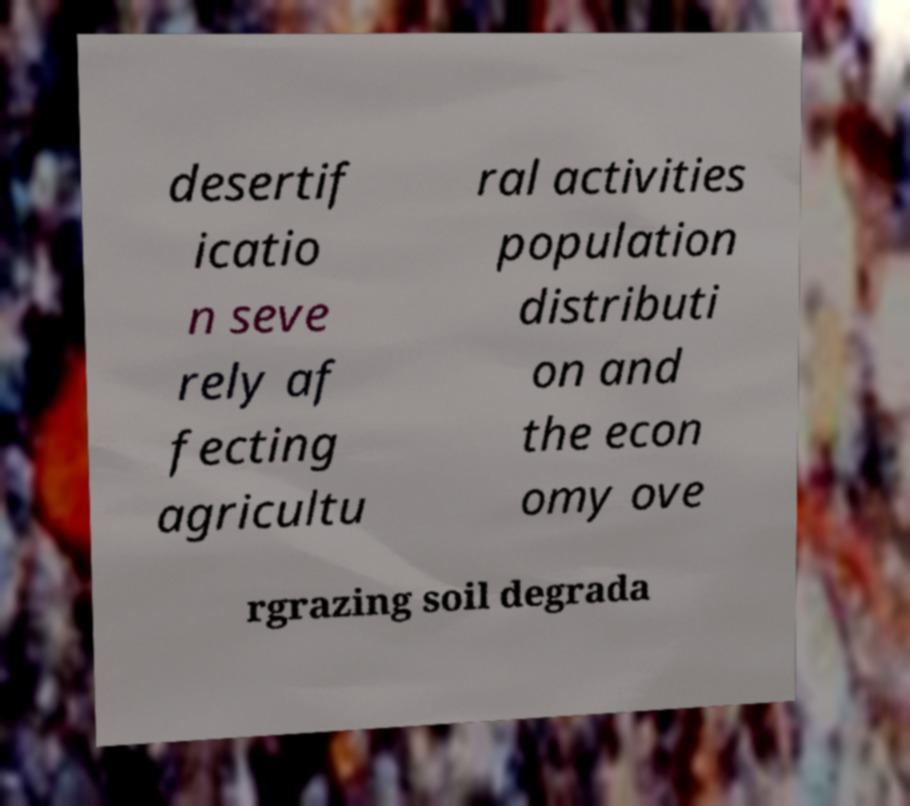Please read and relay the text visible in this image. What does it say? desertif icatio n seve rely af fecting agricultu ral activities population distributi on and the econ omy ove rgrazing soil degrada 